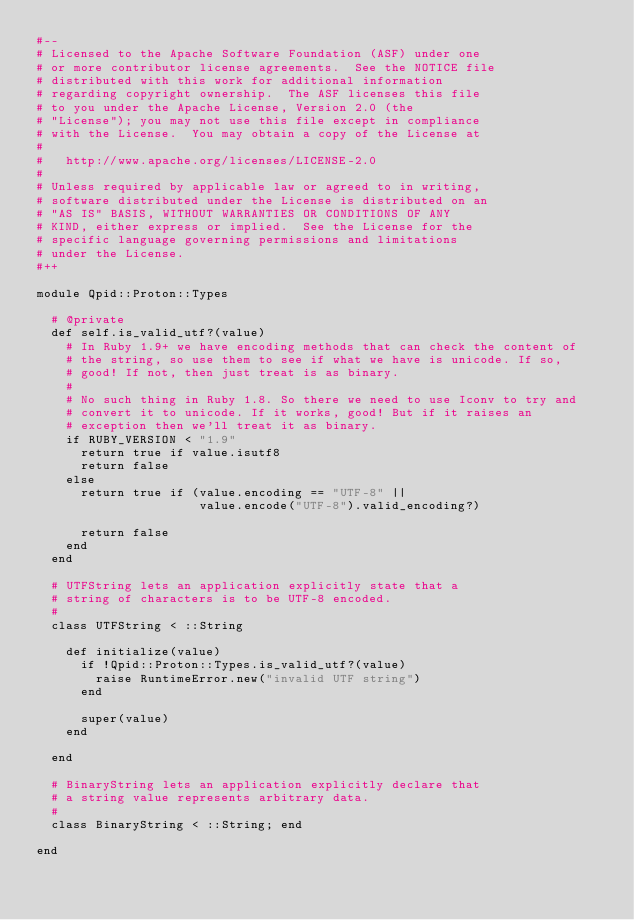<code> <loc_0><loc_0><loc_500><loc_500><_Ruby_>#--
# Licensed to the Apache Software Foundation (ASF) under one
# or more contributor license agreements.  See the NOTICE file
# distributed with this work for additional information
# regarding copyright ownership.  The ASF licenses this file
# to you under the Apache License, Version 2.0 (the
# "License"); you may not use this file except in compliance
# with the License.  You may obtain a copy of the License at
#
#   http://www.apache.org/licenses/LICENSE-2.0
#
# Unless required by applicable law or agreed to in writing,
# software distributed under the License is distributed on an
# "AS IS" BASIS, WITHOUT WARRANTIES OR CONDITIONS OF ANY
# KIND, either express or implied.  See the License for the
# specific language governing permissions and limitations
# under the License.
#++

module Qpid::Proton::Types

  # @private
  def self.is_valid_utf?(value)
    # In Ruby 1.9+ we have encoding methods that can check the content of
    # the string, so use them to see if what we have is unicode. If so,
    # good! If not, then just treat is as binary.
    #
    # No such thing in Ruby 1.8. So there we need to use Iconv to try and
    # convert it to unicode. If it works, good! But if it raises an
    # exception then we'll treat it as binary.
    if RUBY_VERSION < "1.9"
      return true if value.isutf8
      return false
    else
      return true if (value.encoding == "UTF-8" ||
                      value.encode("UTF-8").valid_encoding?)

      return false
    end
  end

  # UTFString lets an application explicitly state that a
  # string of characters is to be UTF-8 encoded.
  #
  class UTFString < ::String

    def initialize(value)
      if !Qpid::Proton::Types.is_valid_utf?(value)
        raise RuntimeError.new("invalid UTF string")
      end

      super(value)
    end

  end

  # BinaryString lets an application explicitly declare that
  # a string value represents arbitrary data.
  #
  class BinaryString < ::String; end

end
</code> 